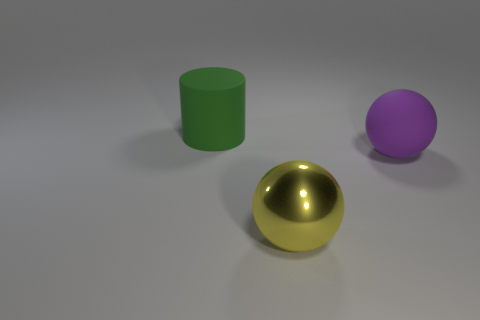What number of other objects are there of the same shape as the purple matte thing?
Make the answer very short. 1. What number of shiny objects are either cyan cubes or big purple spheres?
Offer a very short reply. 0. What is the material of the thing that is behind the matte thing that is on the right side of the green object?
Your answer should be compact. Rubber. Is the number of yellow metal balls that are to the right of the big rubber cylinder greater than the number of cyan objects?
Your response must be concise. Yes. Is there a large purple thing that has the same material as the cylinder?
Keep it short and to the point. Yes. Do the big object that is in front of the rubber ball and the purple matte object have the same shape?
Offer a very short reply. Yes. How many large things are on the left side of the object that is in front of the big rubber thing right of the green rubber thing?
Keep it short and to the point. 1. Are there fewer matte spheres on the left side of the big green matte object than big rubber things that are left of the purple ball?
Offer a terse response. Yes. The other thing that is the same shape as the big metal object is what color?
Offer a very short reply. Purple. How big is the yellow metallic sphere?
Give a very brief answer. Large. 